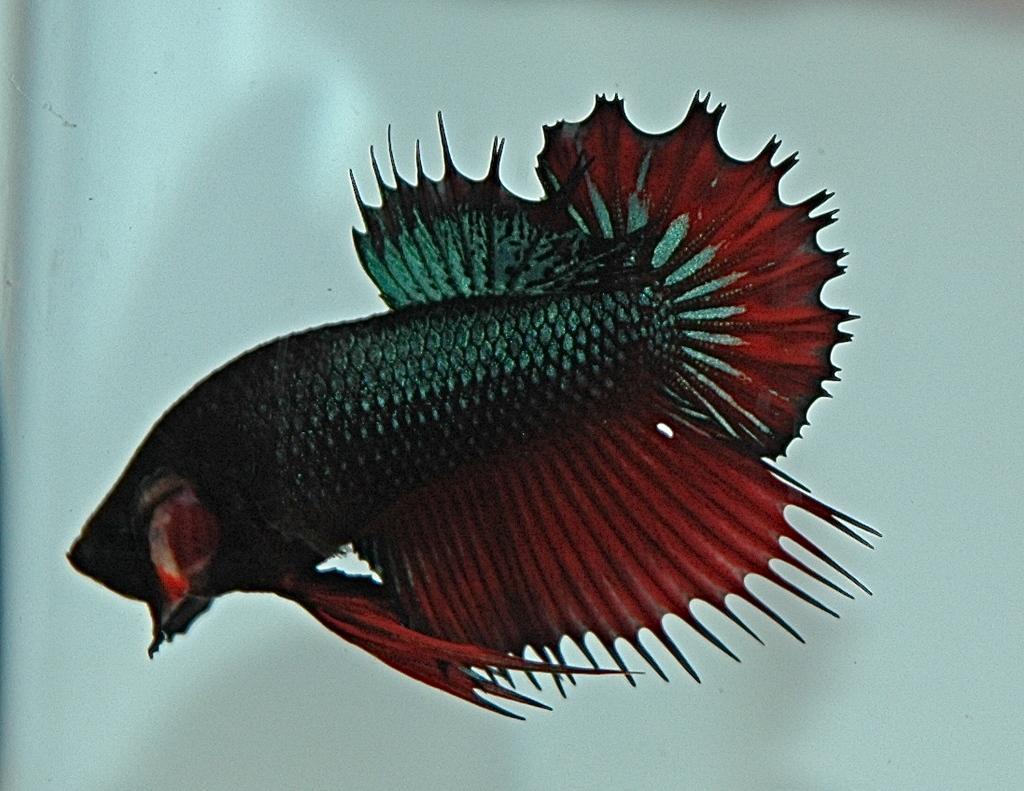How would you summarize this image in a sentence or two? In this image we can see a fish in water. 